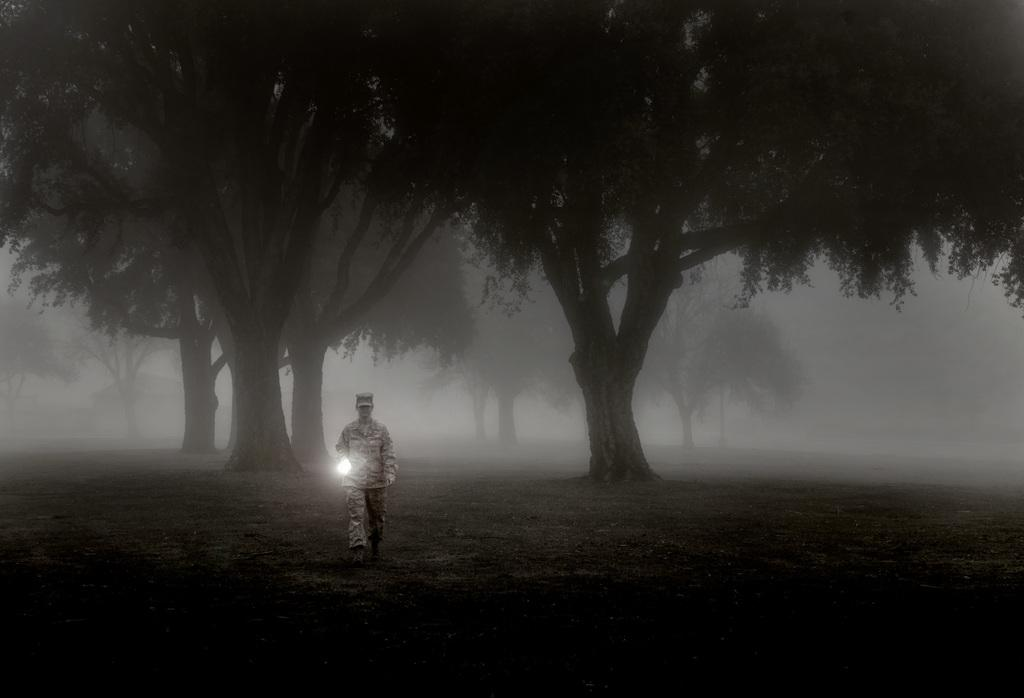What is the man in the image doing? The man is standing in the image and holding a torch light in his hand. What can be seen in the background of the image? There are trees and fog visible in the background of the image. What type of bird is flying through the man's mind in the image? There is no bird present in the image, nor is there any indication of the man's thoughts or mental state. 